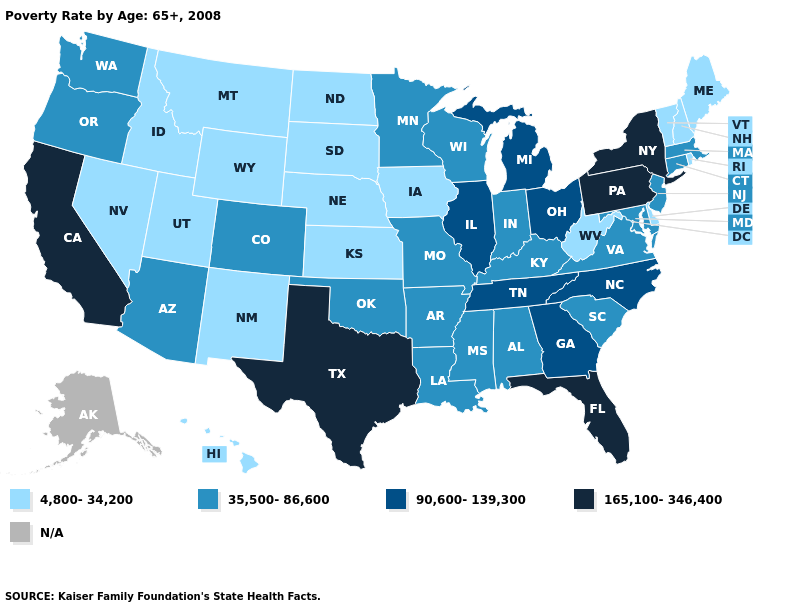Name the states that have a value in the range 35,500-86,600?
Keep it brief. Alabama, Arizona, Arkansas, Colorado, Connecticut, Indiana, Kentucky, Louisiana, Maryland, Massachusetts, Minnesota, Mississippi, Missouri, New Jersey, Oklahoma, Oregon, South Carolina, Virginia, Washington, Wisconsin. What is the value of Idaho?
Concise answer only. 4,800-34,200. What is the value of Connecticut?
Short answer required. 35,500-86,600. What is the value of California?
Answer briefly. 165,100-346,400. Name the states that have a value in the range 165,100-346,400?
Be succinct. California, Florida, New York, Pennsylvania, Texas. Name the states that have a value in the range 165,100-346,400?
Be succinct. California, Florida, New York, Pennsylvania, Texas. What is the value of Georgia?
Answer briefly. 90,600-139,300. What is the highest value in the MidWest ?
Be succinct. 90,600-139,300. Does Nevada have the lowest value in the West?
Concise answer only. Yes. What is the highest value in the West ?
Quick response, please. 165,100-346,400. Among the states that border Maryland , does Pennsylvania have the highest value?
Write a very short answer. Yes. What is the highest value in the MidWest ?
Quick response, please. 90,600-139,300. Which states hav the highest value in the West?
Short answer required. California. Name the states that have a value in the range 4,800-34,200?
Quick response, please. Delaware, Hawaii, Idaho, Iowa, Kansas, Maine, Montana, Nebraska, Nevada, New Hampshire, New Mexico, North Dakota, Rhode Island, South Dakota, Utah, Vermont, West Virginia, Wyoming. 